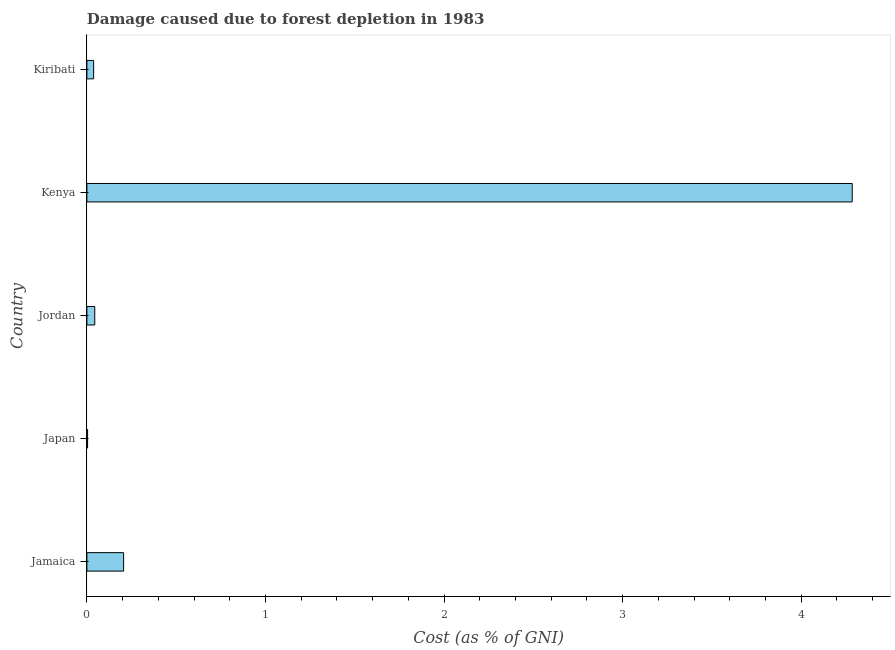Does the graph contain any zero values?
Provide a succinct answer. No. Does the graph contain grids?
Your answer should be compact. No. What is the title of the graph?
Your response must be concise. Damage caused due to forest depletion in 1983. What is the label or title of the X-axis?
Make the answer very short. Cost (as % of GNI). What is the damage caused due to forest depletion in Kiribati?
Ensure brevity in your answer.  0.04. Across all countries, what is the maximum damage caused due to forest depletion?
Offer a very short reply. 4.29. Across all countries, what is the minimum damage caused due to forest depletion?
Your answer should be very brief. 0. In which country was the damage caused due to forest depletion maximum?
Provide a short and direct response. Kenya. What is the sum of the damage caused due to forest depletion?
Ensure brevity in your answer.  4.58. What is the difference between the damage caused due to forest depletion in Jordan and Kiribati?
Keep it short and to the point. 0.01. What is the average damage caused due to forest depletion per country?
Your answer should be very brief. 0.92. What is the median damage caused due to forest depletion?
Your answer should be compact. 0.04. In how many countries, is the damage caused due to forest depletion greater than 1 %?
Give a very brief answer. 1. What is the ratio of the damage caused due to forest depletion in Jamaica to that in Kenya?
Your answer should be compact. 0.05. Is the damage caused due to forest depletion in Kenya less than that in Kiribati?
Offer a very short reply. No. What is the difference between the highest and the second highest damage caused due to forest depletion?
Offer a terse response. 4.08. What is the difference between the highest and the lowest damage caused due to forest depletion?
Give a very brief answer. 4.28. What is the difference between two consecutive major ticks on the X-axis?
Ensure brevity in your answer.  1. What is the Cost (as % of GNI) in Jamaica?
Ensure brevity in your answer.  0.21. What is the Cost (as % of GNI) of Japan?
Your answer should be compact. 0. What is the Cost (as % of GNI) in Jordan?
Ensure brevity in your answer.  0.04. What is the Cost (as % of GNI) of Kenya?
Your response must be concise. 4.29. What is the Cost (as % of GNI) in Kiribati?
Keep it short and to the point. 0.04. What is the difference between the Cost (as % of GNI) in Jamaica and Japan?
Ensure brevity in your answer.  0.2. What is the difference between the Cost (as % of GNI) in Jamaica and Jordan?
Ensure brevity in your answer.  0.16. What is the difference between the Cost (as % of GNI) in Jamaica and Kenya?
Provide a succinct answer. -4.08. What is the difference between the Cost (as % of GNI) in Jamaica and Kiribati?
Provide a short and direct response. 0.17. What is the difference between the Cost (as % of GNI) in Japan and Jordan?
Make the answer very short. -0.04. What is the difference between the Cost (as % of GNI) in Japan and Kenya?
Provide a succinct answer. -4.28. What is the difference between the Cost (as % of GNI) in Japan and Kiribati?
Offer a terse response. -0.03. What is the difference between the Cost (as % of GNI) in Jordan and Kenya?
Your answer should be compact. -4.24. What is the difference between the Cost (as % of GNI) in Jordan and Kiribati?
Offer a terse response. 0.01. What is the difference between the Cost (as % of GNI) in Kenya and Kiribati?
Keep it short and to the point. 4.25. What is the ratio of the Cost (as % of GNI) in Jamaica to that in Japan?
Your response must be concise. 53.12. What is the ratio of the Cost (as % of GNI) in Jamaica to that in Jordan?
Ensure brevity in your answer.  4.67. What is the ratio of the Cost (as % of GNI) in Jamaica to that in Kenya?
Your response must be concise. 0.05. What is the ratio of the Cost (as % of GNI) in Jamaica to that in Kiribati?
Provide a succinct answer. 5.44. What is the ratio of the Cost (as % of GNI) in Japan to that in Jordan?
Make the answer very short. 0.09. What is the ratio of the Cost (as % of GNI) in Japan to that in Kenya?
Offer a terse response. 0. What is the ratio of the Cost (as % of GNI) in Japan to that in Kiribati?
Offer a very short reply. 0.1. What is the ratio of the Cost (as % of GNI) in Jordan to that in Kiribati?
Provide a short and direct response. 1.17. What is the ratio of the Cost (as % of GNI) in Kenya to that in Kiribati?
Offer a very short reply. 113.45. 